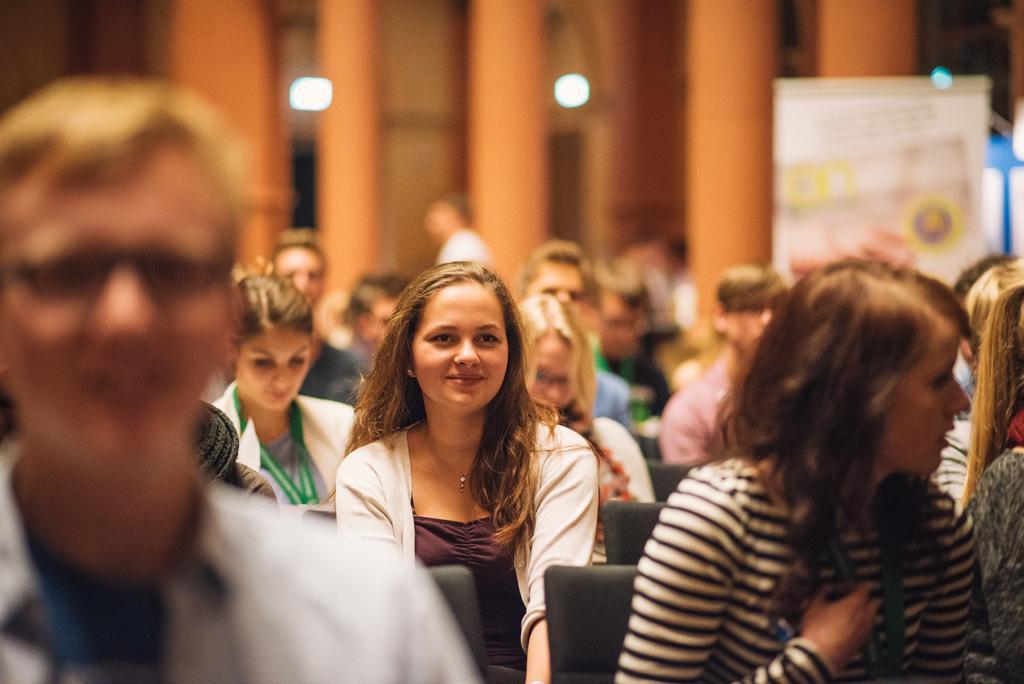Could you give a brief overview of what you see in this image? In this image few people are sitting on the chairs. Right side there is a board. There are pillars. Behind there is a wall having few lights attached to it. 